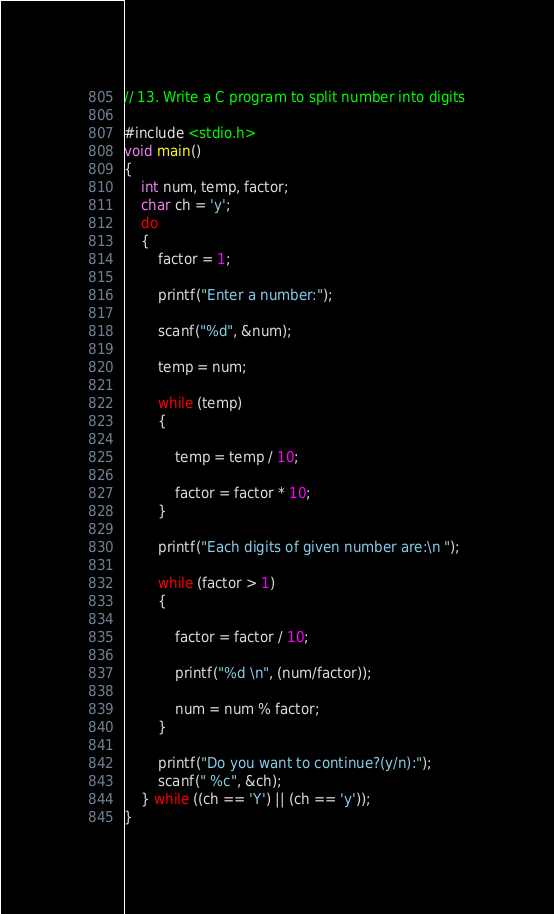<code> <loc_0><loc_0><loc_500><loc_500><_C_>// 13. Write a C program to split number into digits

#include <stdio.h>
void main()
{
    int num, temp, factor;
    char ch = 'y';
    do
    {
        factor = 1;

        printf("Enter a number:");

        scanf("%d", &num);

        temp = num;

        while (temp)
        {

            temp = temp / 10;

            factor = factor * 10;
        }

        printf("Each digits of given number are:\n ");

        while (factor > 1)
        {

            factor = factor / 10;

            printf("%d \n", (num/factor));

            num = num % factor;
        }

        printf("Do you want to continue?(y/n):");
        scanf(" %c", &ch);
    } while ((ch == 'Y') || (ch == 'y'));
}
</code> 